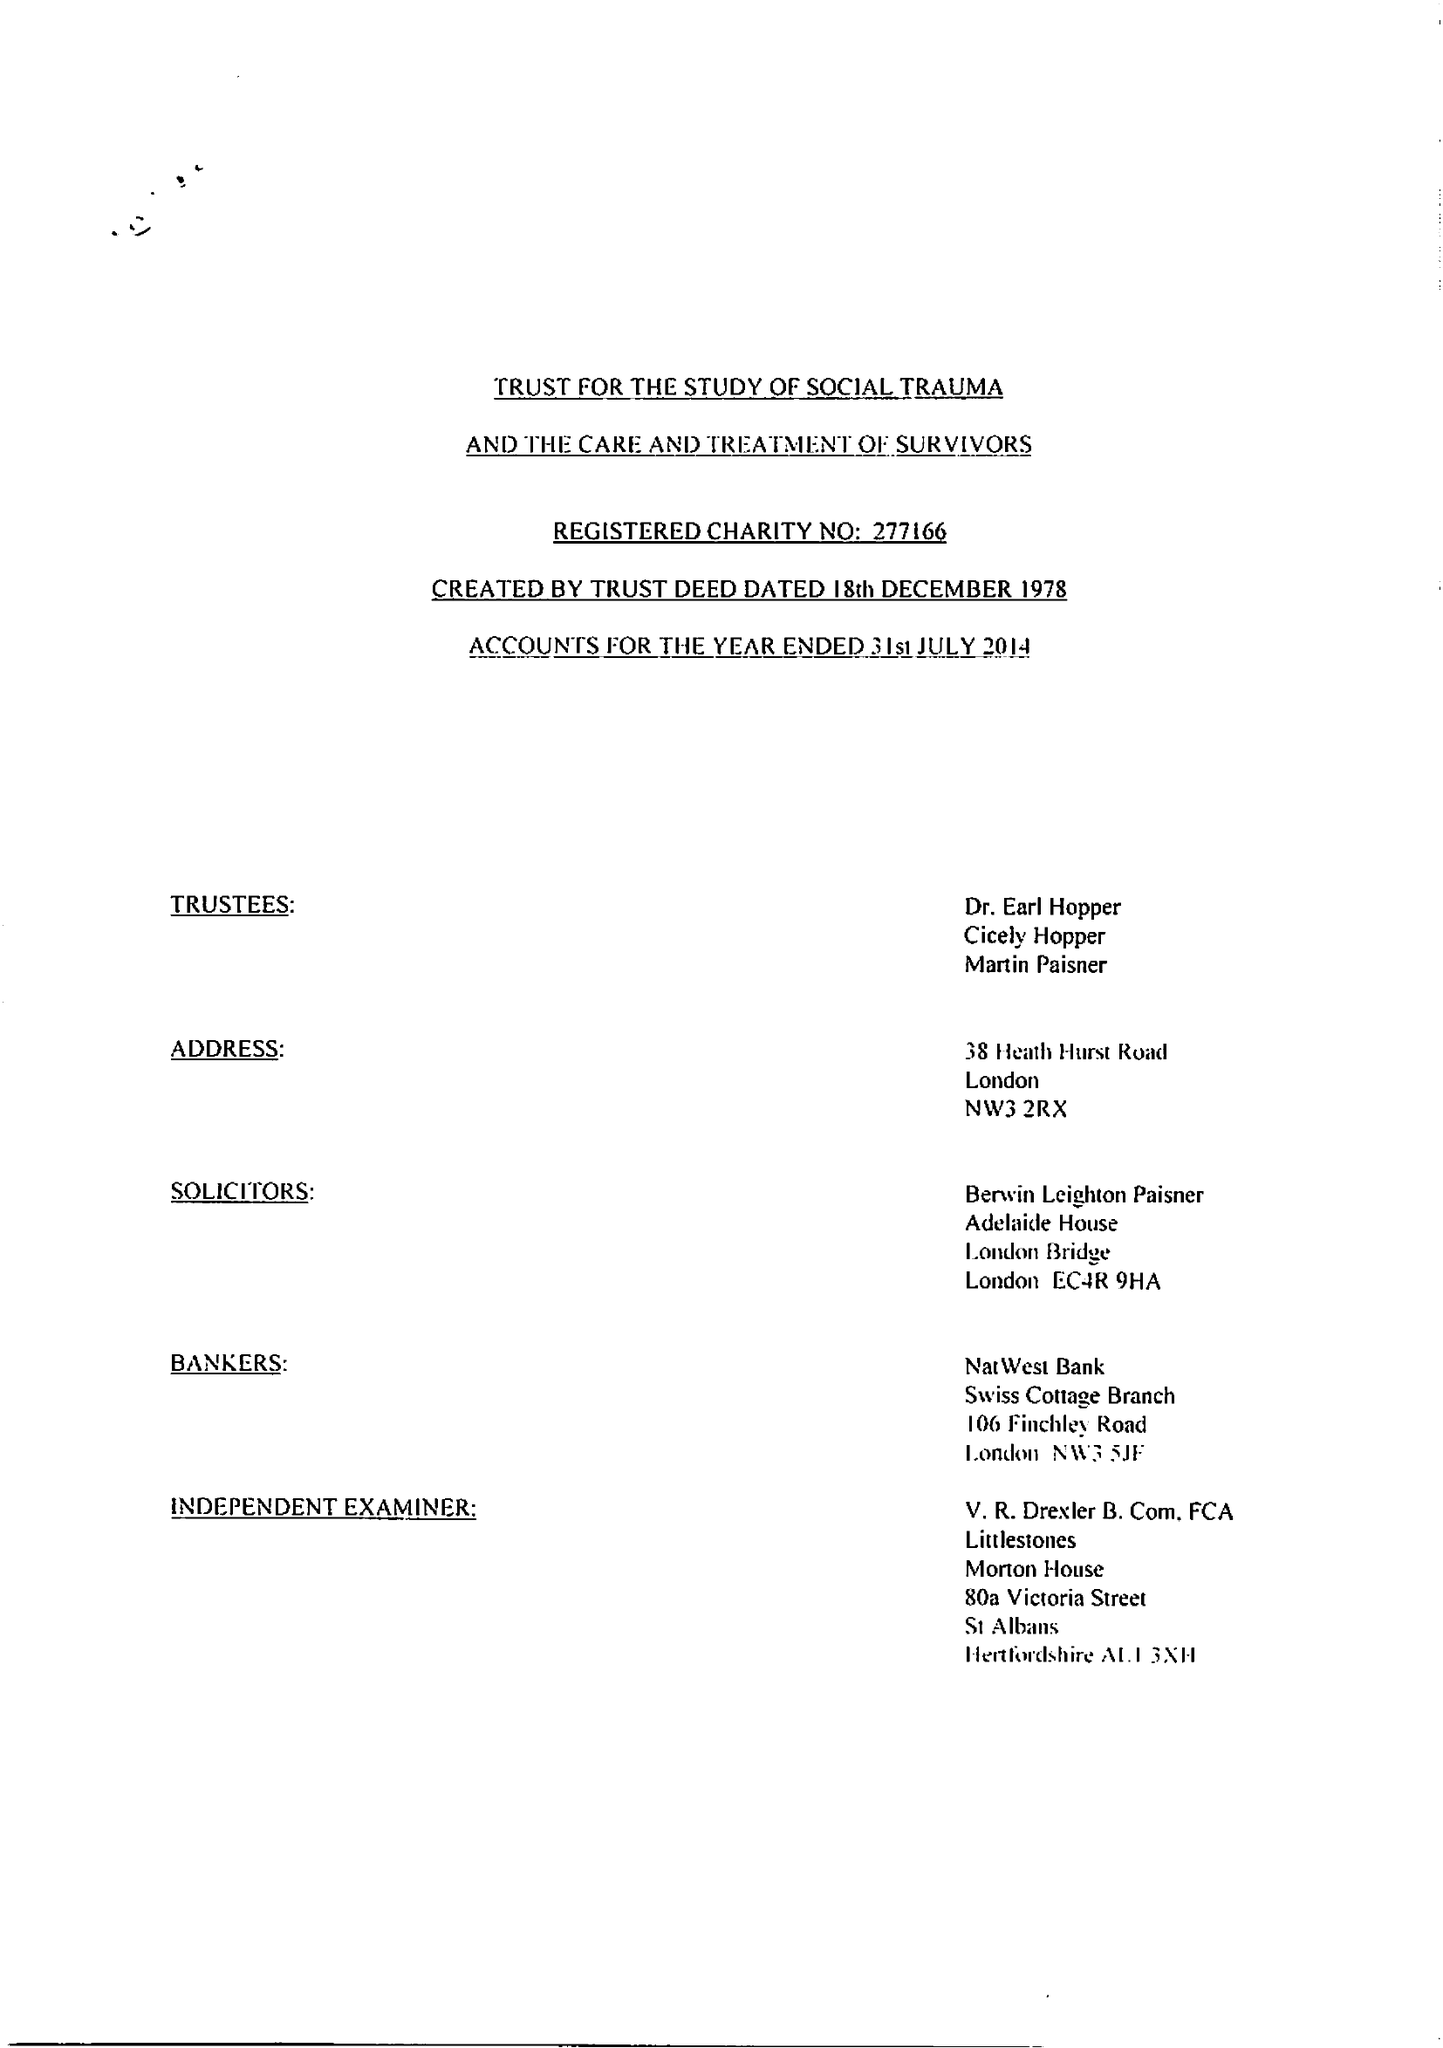What is the value for the address__street_line?
Answer the question using a single word or phrase. 38 HEATH HURST ROAD 